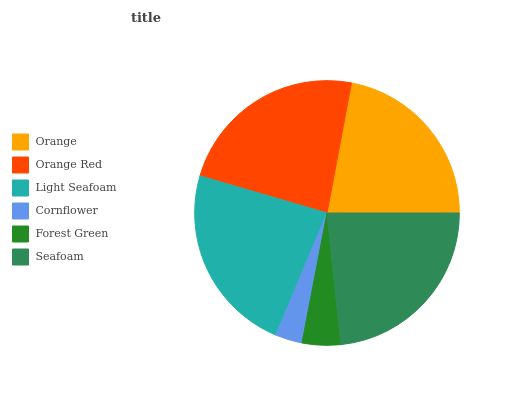Is Cornflower the minimum?
Answer yes or no. Yes. Is Orange Red the maximum?
Answer yes or no. Yes. Is Light Seafoam the minimum?
Answer yes or no. No. Is Light Seafoam the maximum?
Answer yes or no. No. Is Orange Red greater than Light Seafoam?
Answer yes or no. Yes. Is Light Seafoam less than Orange Red?
Answer yes or no. Yes. Is Light Seafoam greater than Orange Red?
Answer yes or no. No. Is Orange Red less than Light Seafoam?
Answer yes or no. No. Is Light Seafoam the high median?
Answer yes or no. Yes. Is Orange the low median?
Answer yes or no. Yes. Is Forest Green the high median?
Answer yes or no. No. Is Cornflower the low median?
Answer yes or no. No. 